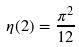<formula> <loc_0><loc_0><loc_500><loc_500>\eta ( 2 ) = \frac { \pi ^ { 2 } } { 1 2 }</formula> 